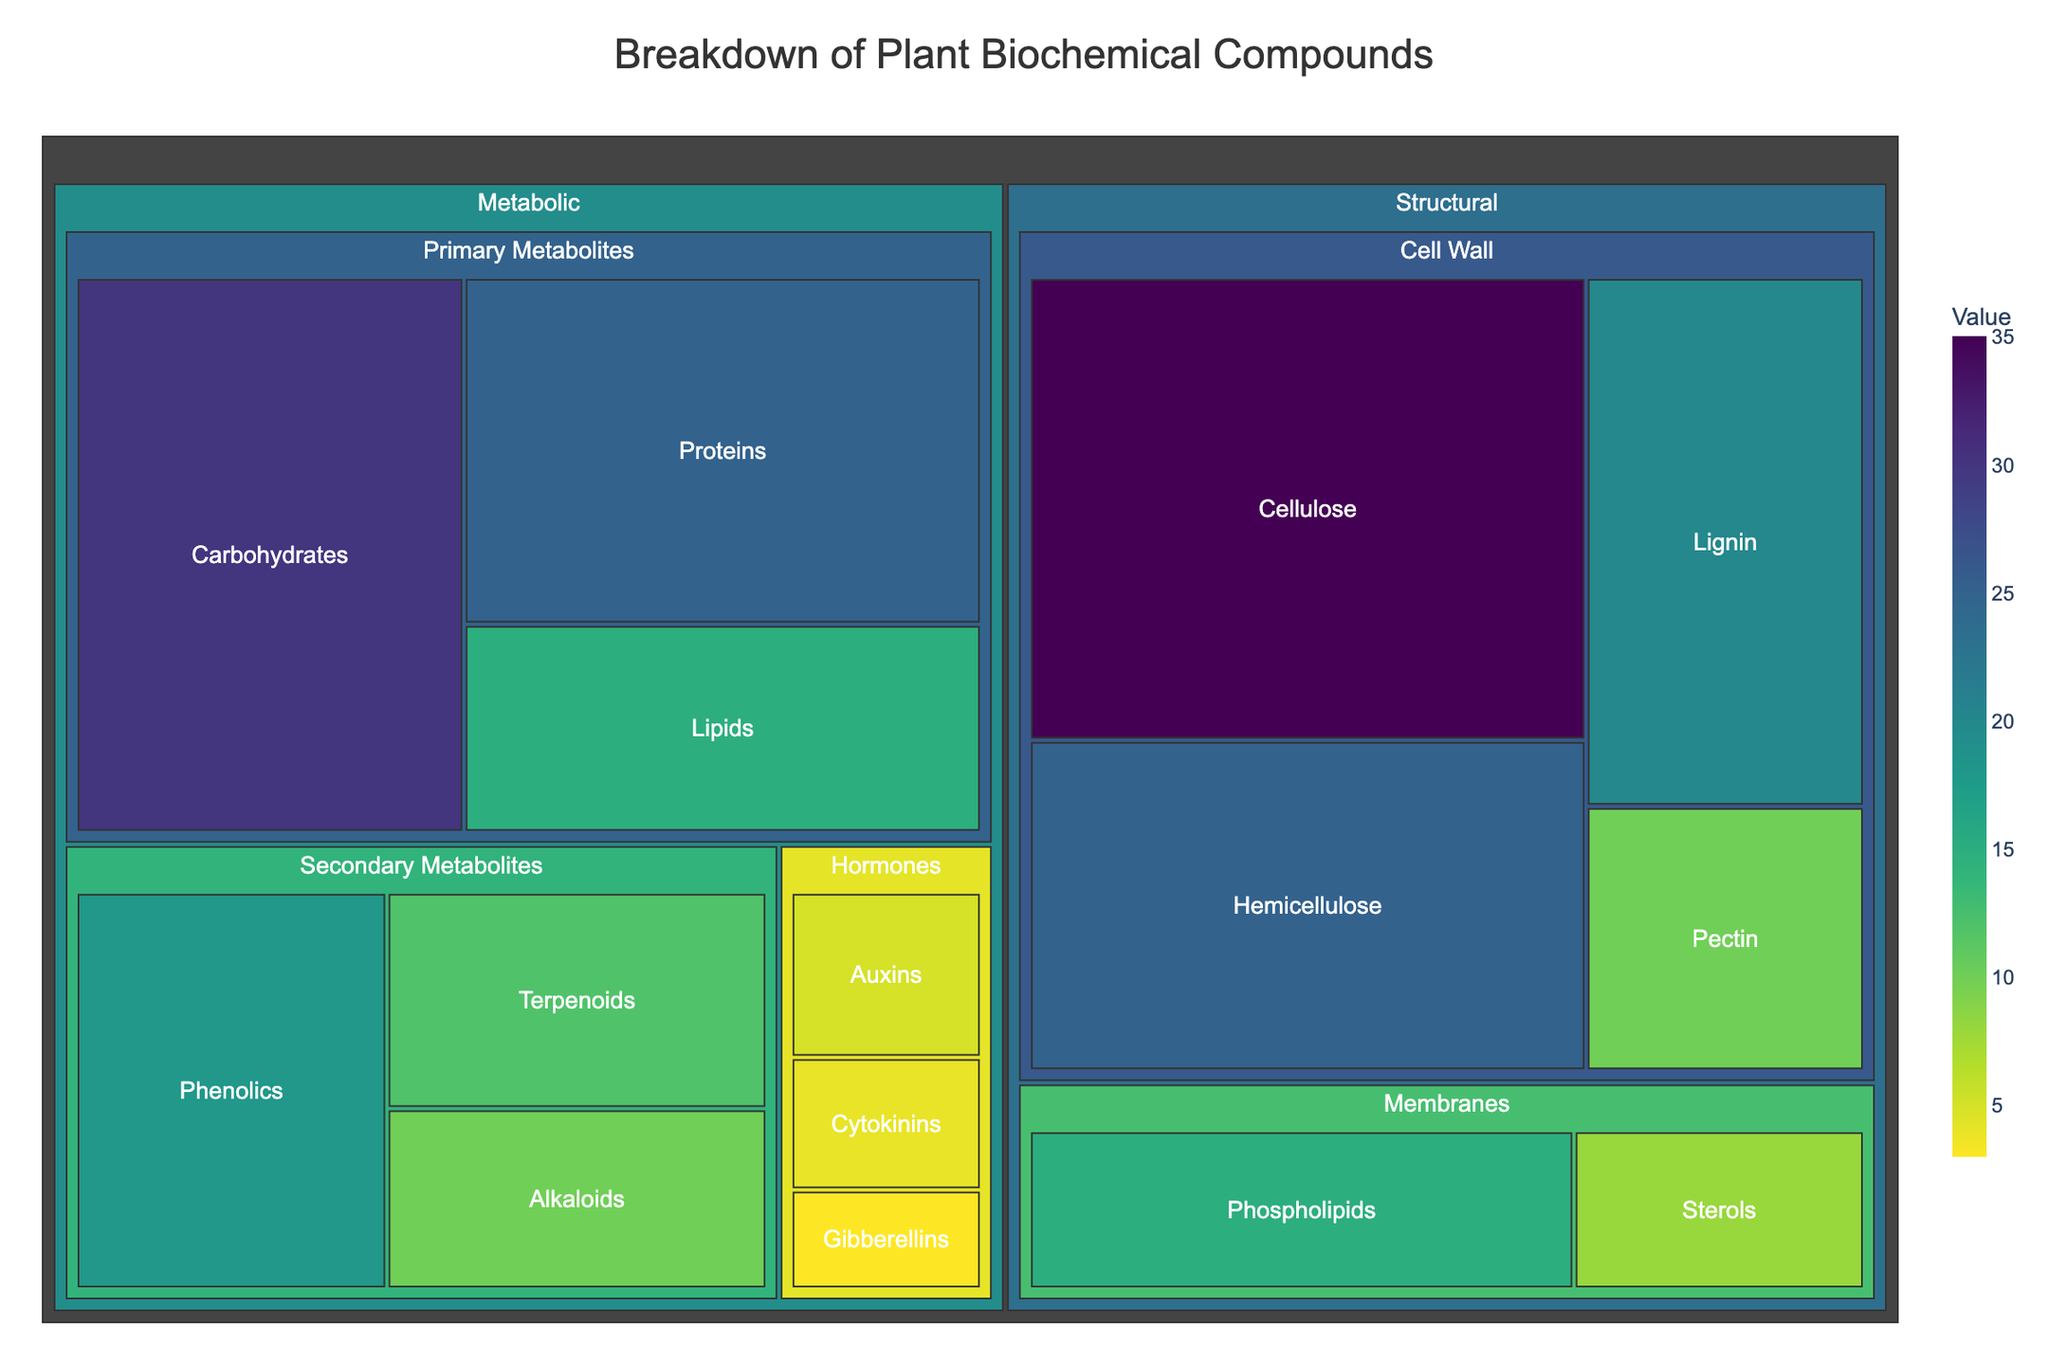What is the title of the Treemap? The title is displayed at the top center of the plot and provides an overview about the data represented in the figure.
Answer: Breakdown of Plant Biochemical Compounds Which compound has the highest value in the Structural category? Look for the largest rectangular area within the "Structural" category, which represents the compound with the highest value.
Answer: Cellulose Which category, Structural or Metabolic, has more compounds? Count the number of subcategories under both Structural and Metabolic categories and sum up the number of compounds in each subcategory. Structural has 7 compounds, while Metabolic has 9.
Answer: Metabolic What are the total values for compounds in the Cell Wall subcategory? Sum up the values of all compounds under the "Cell Wall" subcategory: 35 (Cellulose) + 25 (Hemicellulose) + 20 (Lignin) + 10 (Pectin) = 90.
Answer: 90 What compound in the "Hormones" subcategory has the lowest value? Identify and compare the values of all compounds under the "Hormones" subcategory. The compound with the smallest value is Gibberellins with a value of 3.
Answer: Gibberellins How does the value of "Phenolics" compare to "Terpenoids"? Locate both compounds under the "Secondary Metabolites" subcategory and compare their values. Phenolics has 18, while Terpenoids has 12. Phenolics has a higher value.
Answer: Phenolics has a higher value Which subcategory has the highest total value in the Metabolic category? Calculate the sum of values for each subcategory in the Metabolic category: Primary Metabolites (30 + 25 + 15 = 70), Secondary Metabolites (10 + 12 + 18 = 40), Hormones (5 + 4 + 3 = 12). The highest is Primary Metabolites with 70.
Answer: Primary Metabolites Calculate the percentage of Cellulose in the Structural category. Find the total value of the Structural category by summing its compounds (35 + 25 + 20 + 10 + 15 + 8 = 113). Then, calculate the percentage: (35/113) * 100 ≈ 30.97%.
Answer: 30.97% What are the compounds with values less than 10 in the Metabolic category? Look for compounds in the Metabolic category with values less than 10. They are Alkaloids (10), Auxins (5), Cytokinins (4), and Gibberellins (3).
Answer: Auxins, Cytokinins, Gibberellins, and Alkaloids Which subcategory within Structural has the highest number of compounds? Compare the number of compounds in each subcategory within Structural: Cell Wall has 4 compounds, and Membranes has 2 compounds. Cell Wall has the highest number.
Answer: Cell Wall 